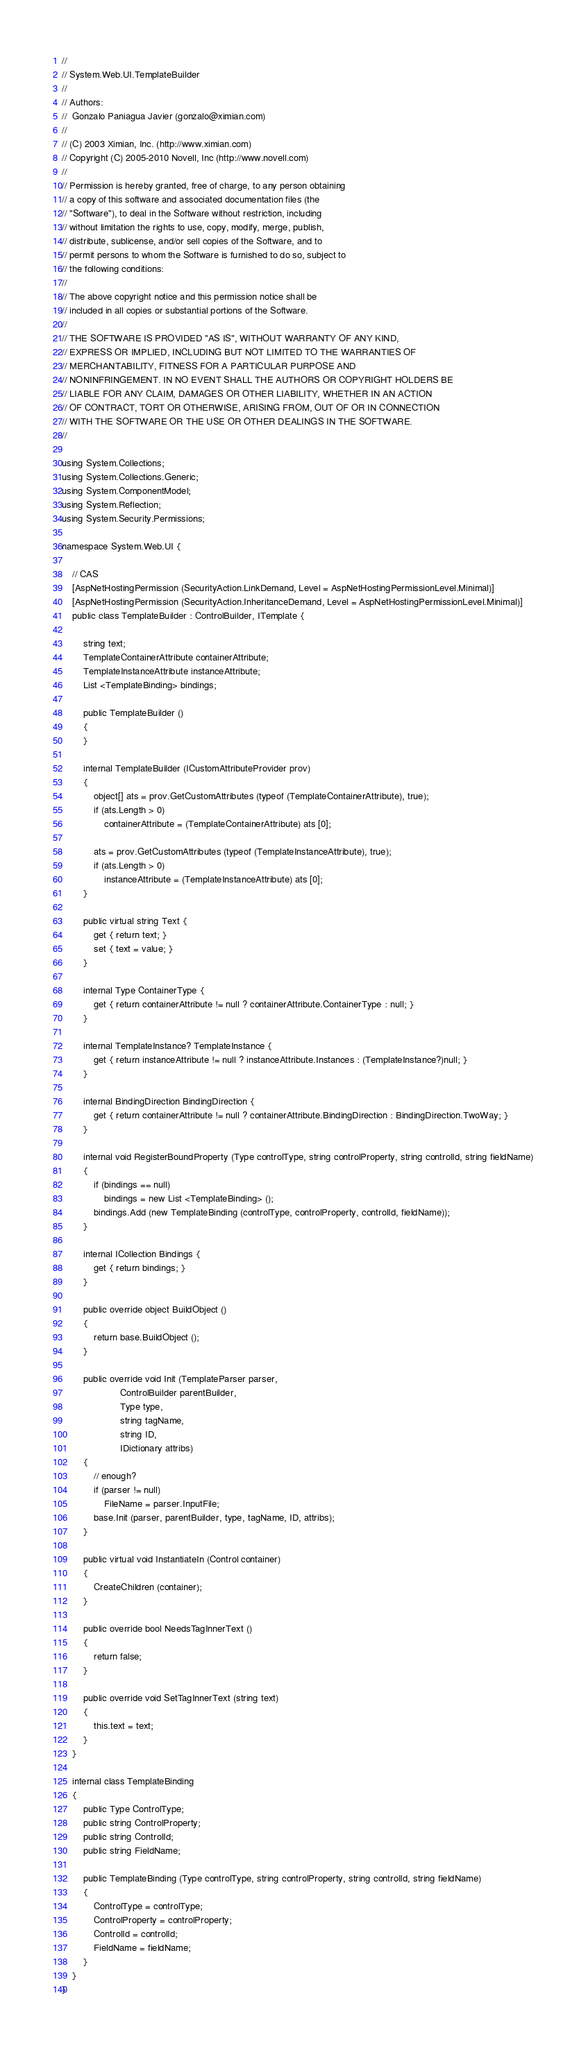Convert code to text. <code><loc_0><loc_0><loc_500><loc_500><_C#_>//
// System.Web.UI.TemplateBuilder
//
// Authors:
//	Gonzalo Paniagua Javier (gonzalo@ximian.com)
//
// (C) 2003 Ximian, Inc. (http://www.ximian.com)
// Copyright (C) 2005-2010 Novell, Inc (http://www.novell.com)
//
// Permission is hereby granted, free of charge, to any person obtaining
// a copy of this software and associated documentation files (the
// "Software"), to deal in the Software without restriction, including
// without limitation the rights to use, copy, modify, merge, publish,
// distribute, sublicense, and/or sell copies of the Software, and to
// permit persons to whom the Software is furnished to do so, subject to
// the following conditions:
// 
// The above copyright notice and this permission notice shall be
// included in all copies or substantial portions of the Software.
// 
// THE SOFTWARE IS PROVIDED "AS IS", WITHOUT WARRANTY OF ANY KIND,
// EXPRESS OR IMPLIED, INCLUDING BUT NOT LIMITED TO THE WARRANTIES OF
// MERCHANTABILITY, FITNESS FOR A PARTICULAR PURPOSE AND
// NONINFRINGEMENT. IN NO EVENT SHALL THE AUTHORS OR COPYRIGHT HOLDERS BE
// LIABLE FOR ANY CLAIM, DAMAGES OR OTHER LIABILITY, WHETHER IN AN ACTION
// OF CONTRACT, TORT OR OTHERWISE, ARISING FROM, OUT OF OR IN CONNECTION
// WITH THE SOFTWARE OR THE USE OR OTHER DEALINGS IN THE SOFTWARE.
//

using System.Collections;
using System.Collections.Generic;
using System.ComponentModel;
using System.Reflection;
using System.Security.Permissions;

namespace System.Web.UI {

	// CAS
	[AspNetHostingPermission (SecurityAction.LinkDemand, Level = AspNetHostingPermissionLevel.Minimal)]
	[AspNetHostingPermission (SecurityAction.InheritanceDemand, Level = AspNetHostingPermissionLevel.Minimal)]
	public class TemplateBuilder : ControlBuilder, ITemplate {

		string text;
		TemplateContainerAttribute containerAttribute;
		TemplateInstanceAttribute instanceAttribute;
		List <TemplateBinding> bindings;

		public TemplateBuilder ()
		{
		}

		internal TemplateBuilder (ICustomAttributeProvider prov)
		{
			object[] ats = prov.GetCustomAttributes (typeof (TemplateContainerAttribute), true);
			if (ats.Length > 0)
				containerAttribute = (TemplateContainerAttribute) ats [0];

			ats = prov.GetCustomAttributes (typeof (TemplateInstanceAttribute), true);
			if (ats.Length > 0)
				instanceAttribute = (TemplateInstanceAttribute) ats [0];
		}

		public virtual string Text {
			get { return text; }
			set { text = value; }
		}
		
		internal Type ContainerType {
			get { return containerAttribute != null ? containerAttribute.ContainerType : null; }
		}
		
		internal TemplateInstance? TemplateInstance {
			get { return instanceAttribute != null ? instanceAttribute.Instances : (TemplateInstance?)null; }
		}
					
		internal BindingDirection BindingDirection {
			get { return containerAttribute != null ? containerAttribute.BindingDirection : BindingDirection.TwoWay; }
		}
		
		internal void RegisterBoundProperty (Type controlType, string controlProperty, string controlId, string fieldName)
		{
			if (bindings == null)
				bindings = new List <TemplateBinding> ();
			bindings.Add (new TemplateBinding (controlType, controlProperty, controlId, fieldName));
		}
		
		internal ICollection Bindings {
			get { return bindings; }
		}

		public override object BuildObject ()
		{
			return base.BuildObject ();
		}

		public override void Init (TemplateParser parser,
					  ControlBuilder parentBuilder,
					  Type type,
					  string tagName,
					  string ID,
					  IDictionary attribs)
		{
			// enough?
			if (parser != null)
				FileName = parser.InputFile;
			base.Init (parser, parentBuilder, type, tagName, ID, attribs);
		}
		
		public virtual void InstantiateIn (Control container)
		{
			CreateChildren (container);
		}

		public override bool NeedsTagInnerText ()
		{
			return false;
		}

		public override void SetTagInnerText (string text)
		{
			this.text = text;
		}
	}
	
	internal class TemplateBinding
	{
		public Type ControlType;
		public string ControlProperty;
		public string ControlId;
		public string FieldName;
		
		public TemplateBinding (Type controlType, string controlProperty, string controlId, string fieldName)
		{
			ControlType = controlType;
			ControlProperty = controlProperty;
			ControlId = controlId;
			FieldName = fieldName;
		}
	}
}

</code> 